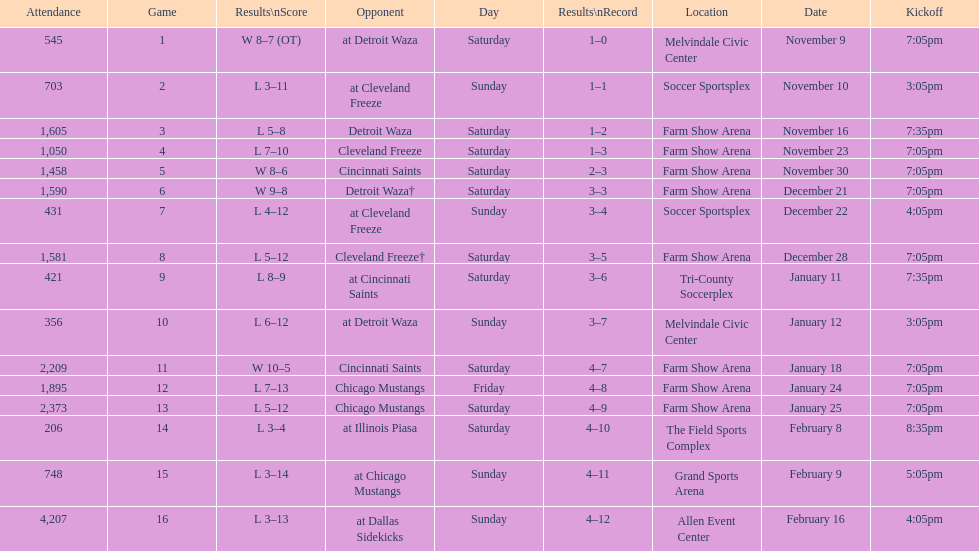What is the date of the game after december 22? December 28. 